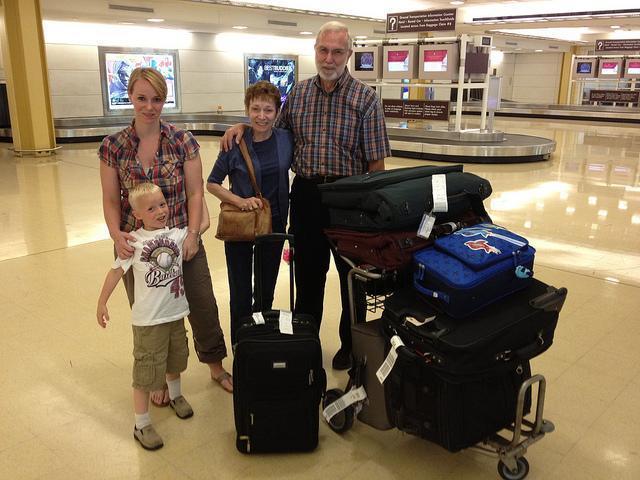How many children are in the picture?
Give a very brief answer. 1. How many suitcases are there?
Give a very brief answer. 7. How many people are in the photo?
Give a very brief answer. 4. 